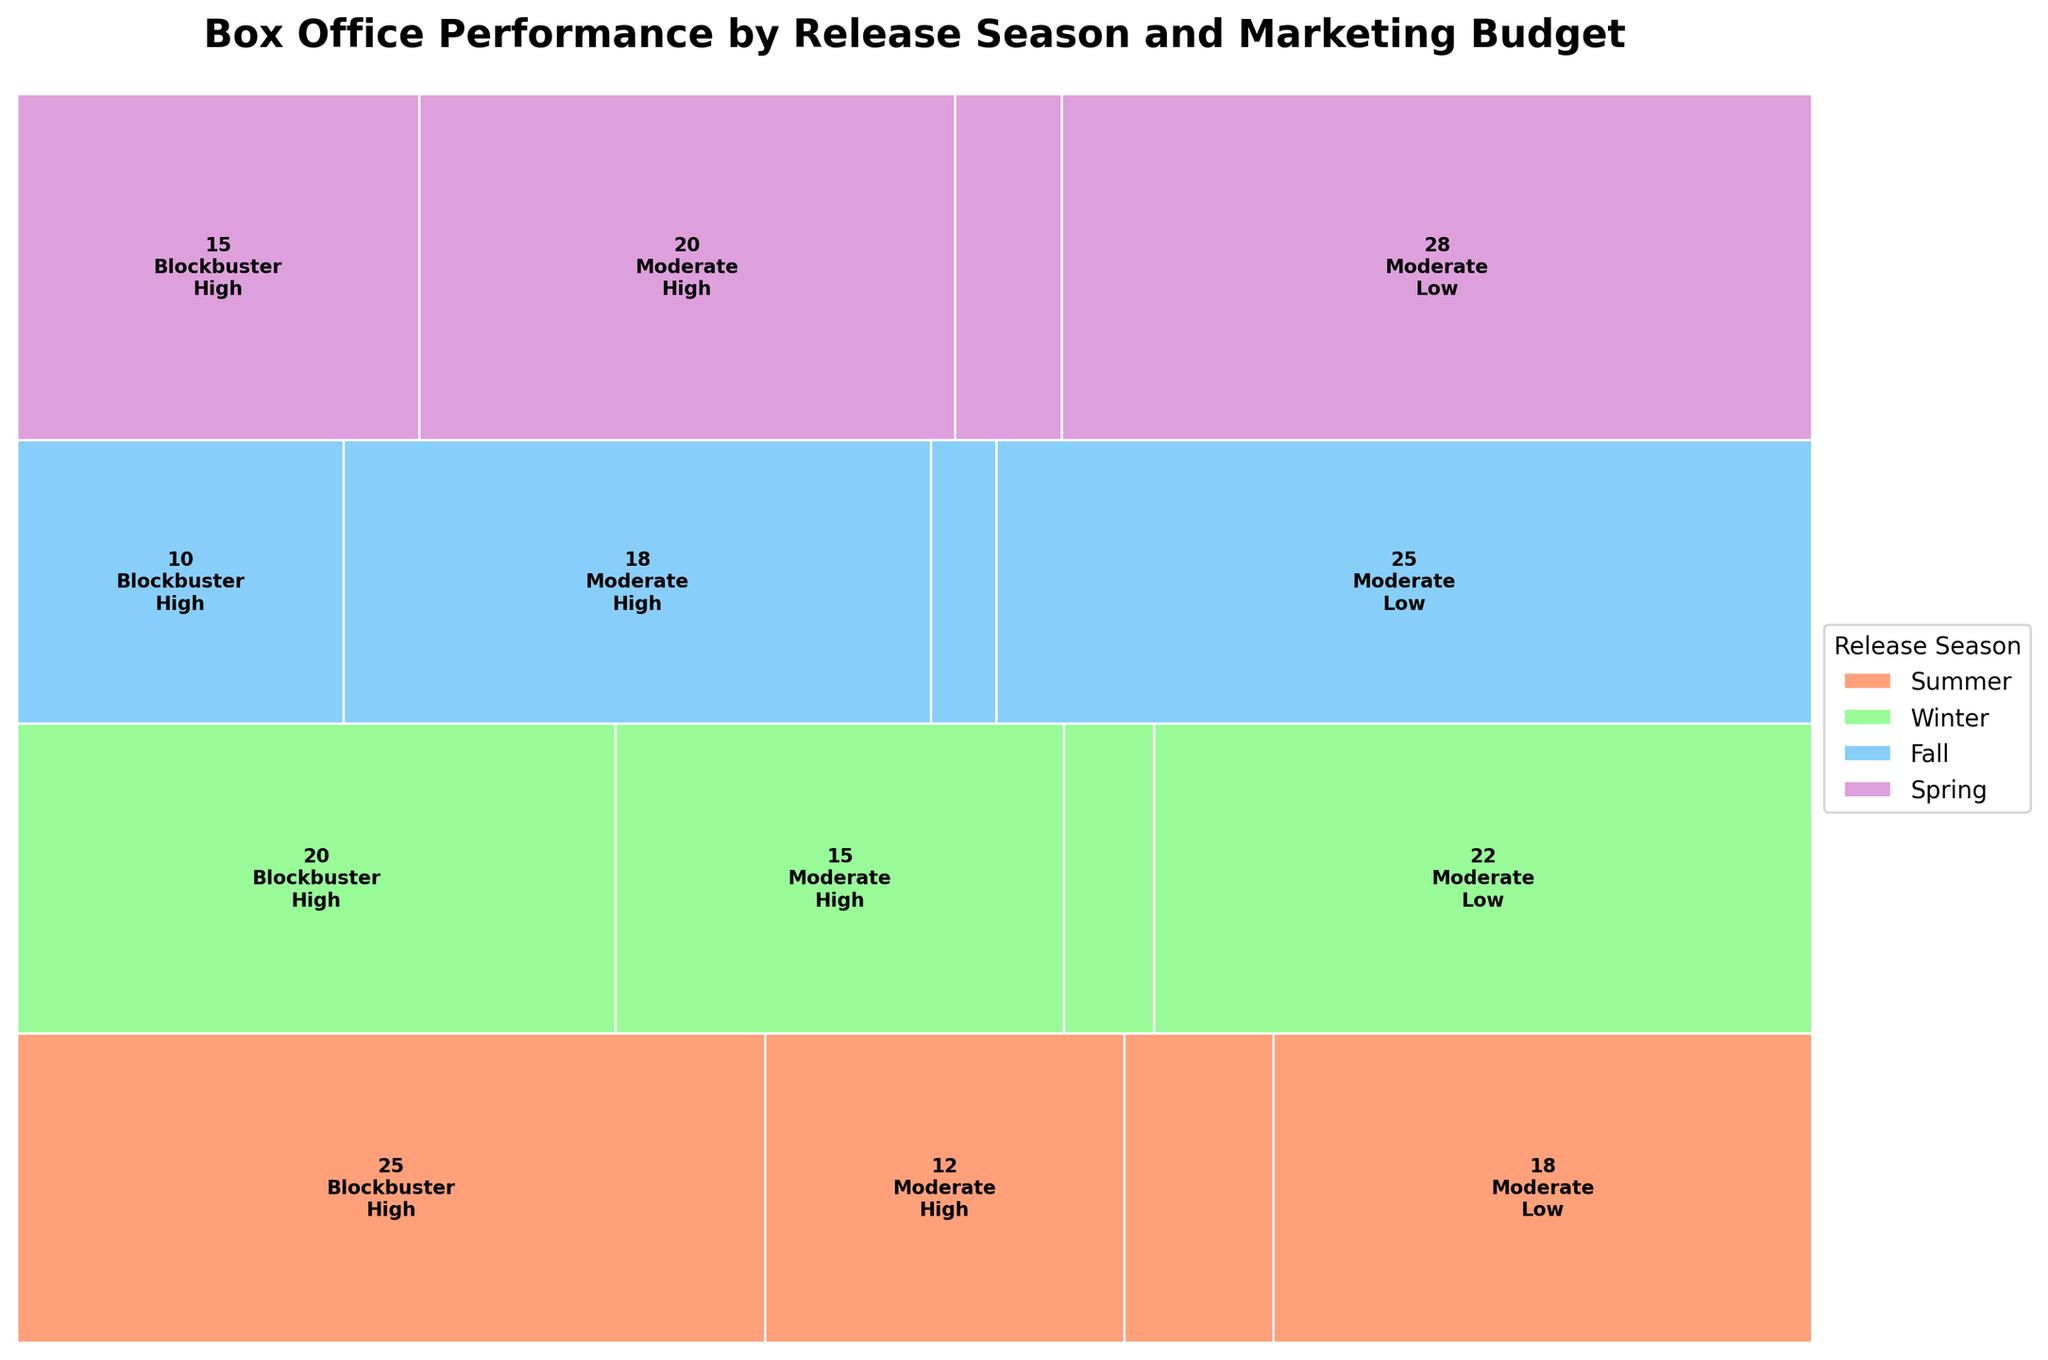What is the title of the plot? The title of the plot is usually found at the top of the figure and gives a summary of what the plot is about. Here, it should mention the main variables being visualized.
Answer: Box Office Performance by Release Season and Marketing Budget How many release seasons are represented in the plot? Observing the different colored sections in the plot, which represent the release seasons, count the total number of unique colors (each representing a release season).
Answer: 4 Which release season has the highest number of films with a low marketing budget and moderate box office performance? To determine this, look at the rectangles representing each season, budget, and performance combination. Identify which of these has the largest area among those with low marketing budgets and moderate box office performance.
Answer: Spring Which combination has a higher film count: Summer with high marketing budgets and blockbuster performance or Winter with low marketing budgets and moderate performance? This requires a comparison between two specific rectangles: one for Summer with high marketing budgets and blockbuster performance, and the other for Winter with low marketing budgets and moderate performance. Observe the film count within each.
Answer: Winter with low marketing budgets and moderate performance How many films were blockbusters in Fall with high marketing budgets? Locate the section of the plot corresponding to Fall entries with high marketing budgets and blockbuster performances. The number will be displayed within the rectangle.
Answer: 10 Which season has an equal number of blockbuster films under both high and low marketing budgets? Check each season and sum up the film counts under high and low marketing budgets for blockbuster performance. Find a season where these sums are equal.
Answer: None In which release season are films with low marketing budgets the most common? Add up the film counts for moderate and blockbuster performances under low marketing budgets for each season. Identify the season with the highest total count.
Answer: Spring Compare the number of moderate box office performance films between high and low marketing budgets in Winter. Locate the counts for Winter with moderate box office performance under both high and low marketing budgets. Subtract the lower count from the higher to determine which budget has more films.
Answer: High marketing budgets What is the proportion of blockbusters in Summer with high marketing budgets relative to total blockbusters? First, sum the counts of all blockbusters across all seasons and budgets. Then, divide the count of blockbusters in Summer with high marketing budgets by this total.
Answer: 25/84 ≈ 0.298 (about 29.8%) Which marketing budget category is most successful in producing blockbusters overall? Sum the number of blockbusters for high and low marketing budgets across all seasons. Compare these sums to determine which budget has the higher count.
Answer: High marketing budgets 